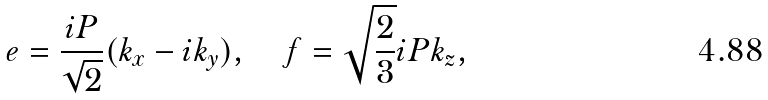Convert formula to latex. <formula><loc_0><loc_0><loc_500><loc_500>e = \frac { i P } { \sqrt { 2 } } ( k _ { x } - i k _ { y } ) , \quad f = \sqrt { \frac { 2 } { 3 } } i P k _ { z } ,</formula> 